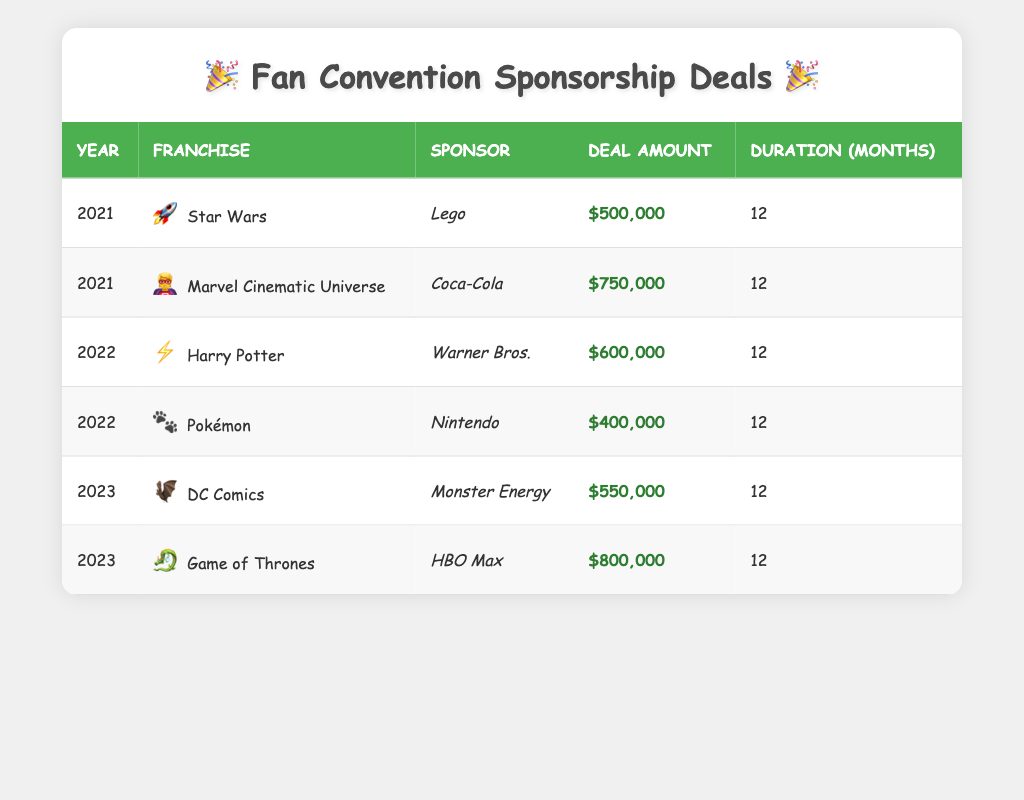What is the deal amount for the Marvel Cinematic Universe in 2021? From the table, we can see that for the year 2021, the franchise Marvel Cinematic Universe has a deal amount of $750,000 listed next to it.
Answer: $750,000 Which franchise received the lowest sponsorship deal amount in 2022? Looking at the year 2022, there are two franchises listed: Harry Potter with a deal amount of $600,000 and Pokémon with a deal amount of $400,000. The lowest amount is associated with Pokémon.
Answer: Pokémon How much was the total deal amount for sponsorship deals in the year 2023? In 2023, there are two deals: DC Comics for $550,000 and Game of Thrones for $800,000. Adding these amounts gives us $550,000 + $800,000 = $1,350,000 for that year.
Answer: $1,350,000 Was any sponsorship deal longer than 12 months? The table shows all deals specify a duration of 12 months, thus there is no deal longer than that duration.
Answer: No Which sponsor had the highest deal amount overall? Analyzing the deal amounts, we have Lego at $500,000, Coca-Cola at $750,000, Warner Bros. at $600,000, Nintendo at $400,000, Monster Energy at $550,000, and HBO Max at $800,000. HBO Max with $800,000 is the highest.
Answer: HBO Max What is the average deal amount for sponsorship deals across all years? The deal amounts listed are $500,000, $750,000, $600,000, $400,000, $550,000, and $800,000. The sum of these amounts is $3,600,000. Since there are 6 deals, the average is $3,600,000 / 6 = $600,000.
Answer: $600,000 Did Lego sponsor any franchises in 2022? According to the table, Lego is listed as the sponsor only for the Star Wars franchise in 2021 and is not associated with any franchises in 2022.
Answer: No How many different franchises were sponsored across the years? In the table, we see six unique franchises: Star Wars, Marvel Cinematic Universe, Harry Potter, Pokémon, DC Comics, and Game of Thrones, totaling six franchises.
Answer: 6 What was the deal amount for Pokémon, and how does it compare to the average deal amount? Pokémon had a deal amount of $400,000. The average deal amount is $600,000; hence Pokémon's amount is $200,000 lower than the average.
Answer: $400,000, $200,000 lower than average 